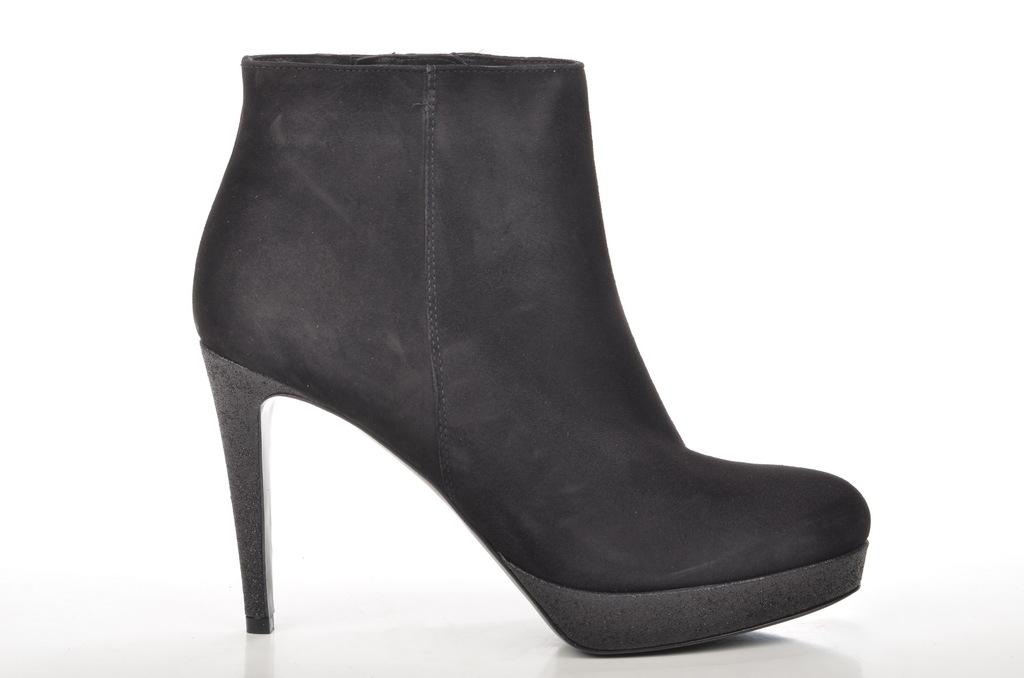What type of footwear is visible in the image? There is a woman's heel shoe in the image. What color is the shoe in the image? The shoe is black in color. What type of tray is being used to transport the shoe in the image? There is no tray or transportation of the shoe depicted in the image; it is simply a shoe lying on its side. What type of engine can be seen powering the shoe in the image? There is no engine present in the image, as the shoe is an inanimate object and does not require power to function. 